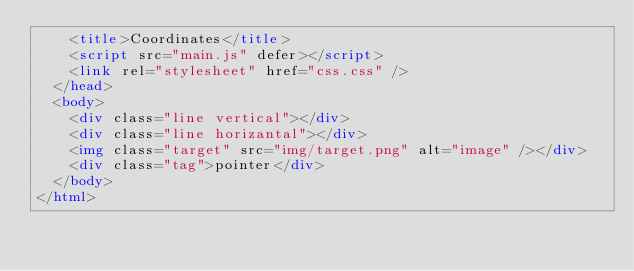Convert code to text. <code><loc_0><loc_0><loc_500><loc_500><_HTML_>    <title>Coordinates</title>
    <script src="main.js" defer></script>
    <link rel="stylesheet" href="css.css" />
  </head>
  <body>
    <div class="line vertical"></div>
    <div class="line horizantal"></div>
    <img class="target" src="img/target.png" alt="image" /></div>
    <div class="tag">pointer</div>
  </body>
</html>
</code> 